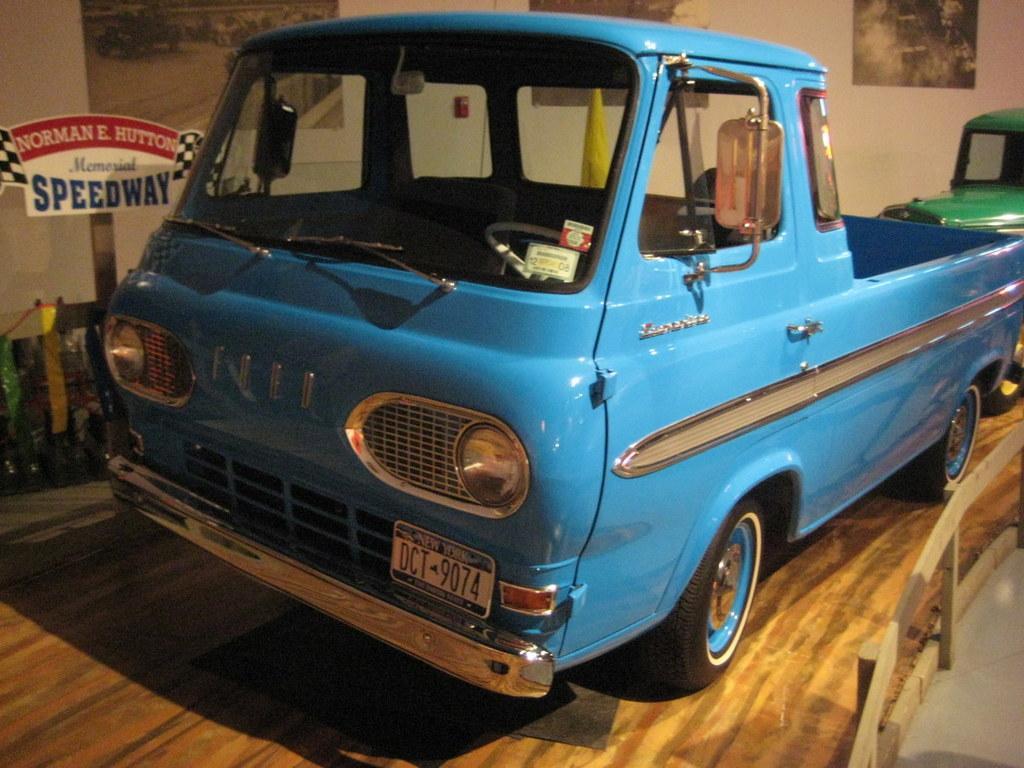Could you give a brief overview of what you see in this image? In this image there are blue and green color vehicles, wooden fence, board , papers stick to the wall. 